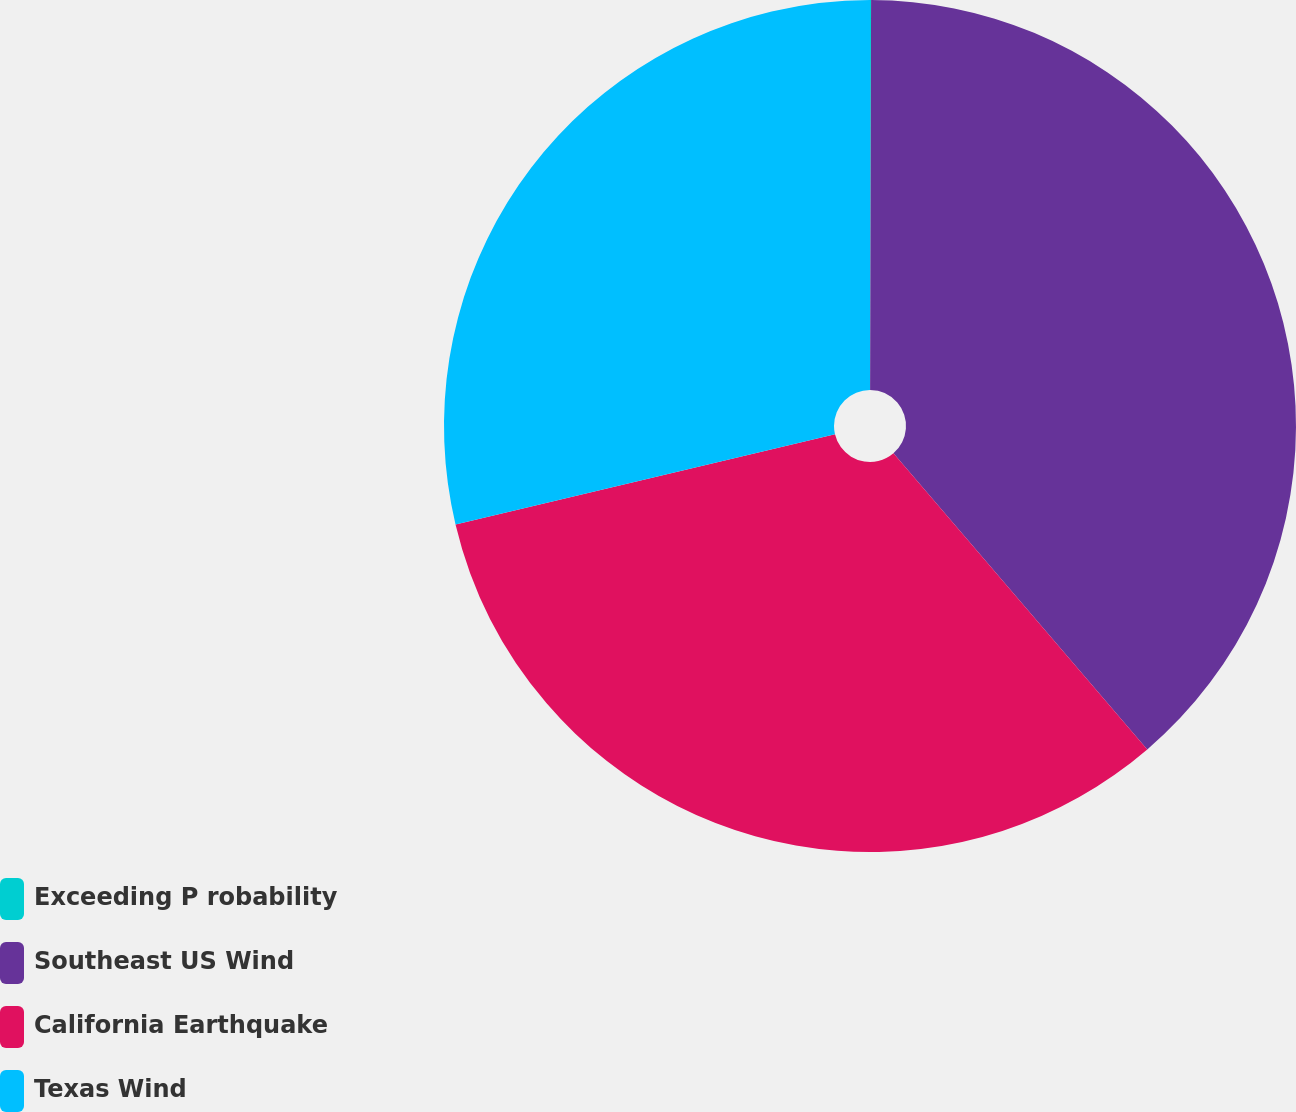<chart> <loc_0><loc_0><loc_500><loc_500><pie_chart><fcel>Exceeding P robability<fcel>Southeast US Wind<fcel>California Earthquake<fcel>Texas Wind<nl><fcel>0.04%<fcel>38.68%<fcel>32.57%<fcel>28.71%<nl></chart> 